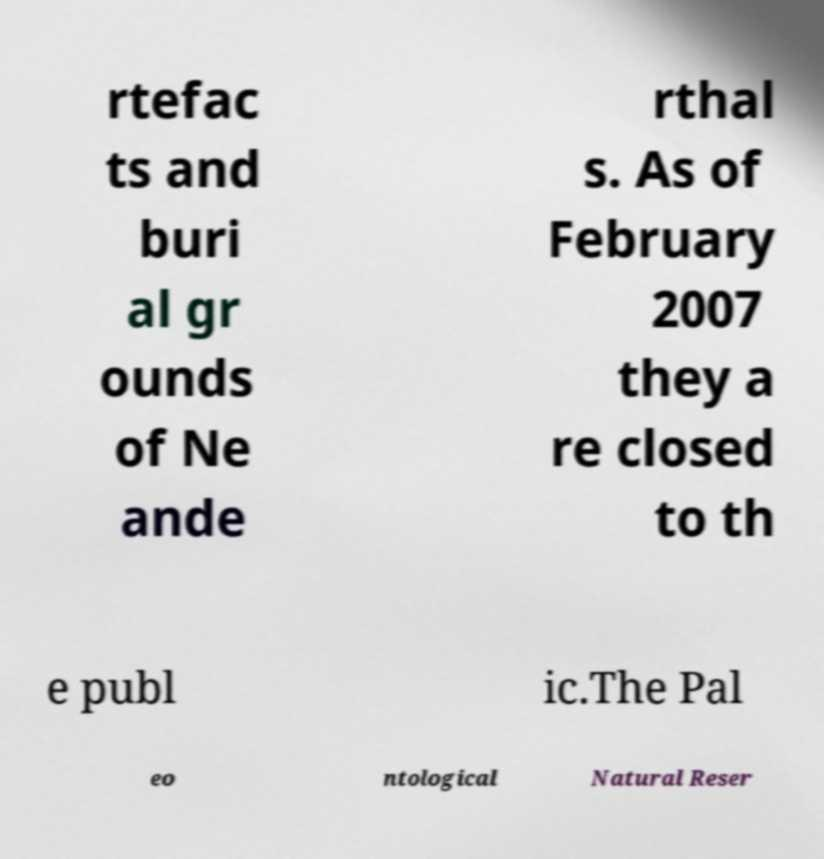Could you extract and type out the text from this image? rtefac ts and buri al gr ounds of Ne ande rthal s. As of February 2007 they a re closed to th e publ ic.The Pal eo ntological Natural Reser 